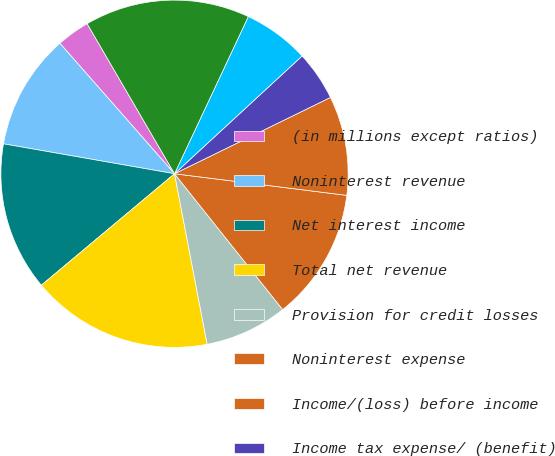Convert chart to OTSL. <chart><loc_0><loc_0><loc_500><loc_500><pie_chart><fcel>(in millions except ratios)<fcel>Noninterest revenue<fcel>Net interest income<fcel>Total net revenue<fcel>Provision for credit losses<fcel>Noninterest expense<fcel>Income/(loss) before income<fcel>Income tax expense/ (benefit)<fcel>Net income/(loss)<fcel>Average common equity<nl><fcel>3.08%<fcel>10.77%<fcel>13.85%<fcel>16.92%<fcel>7.69%<fcel>12.31%<fcel>9.23%<fcel>4.62%<fcel>6.15%<fcel>15.38%<nl></chart> 